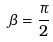<formula> <loc_0><loc_0><loc_500><loc_500>\beta = { \frac { \pi } { 2 } }</formula> 